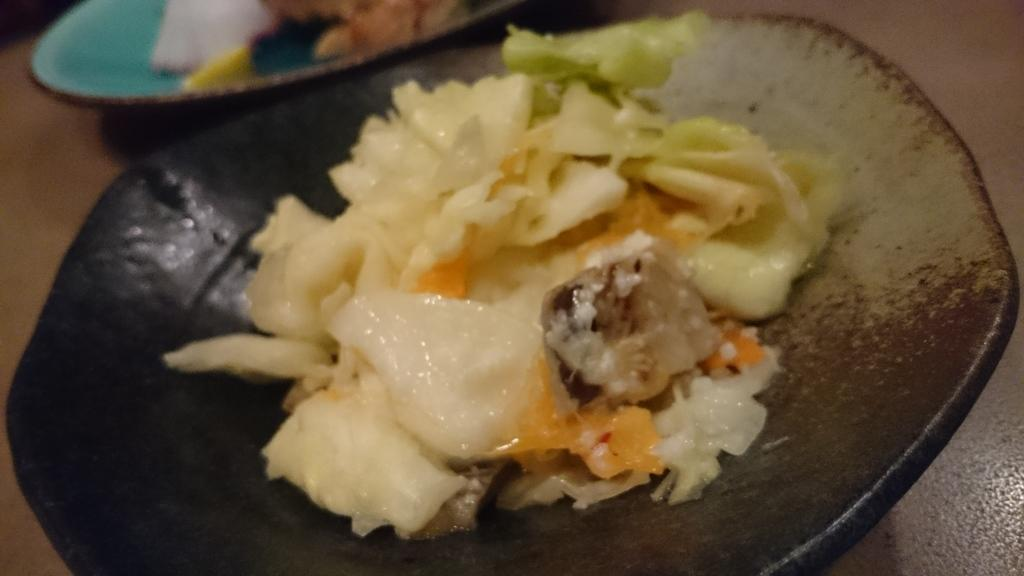What objects are on the table in the image? There are plates on the table. What is on the plates? There is food on the plates. How are the dolls being sorted on the table in the image? There are no dolls present in the image; it only shows plates with food on them. What type of boats can be seen sailing in the background of the image? There is no background or boats visible in the image; it only shows plates with food on them. 